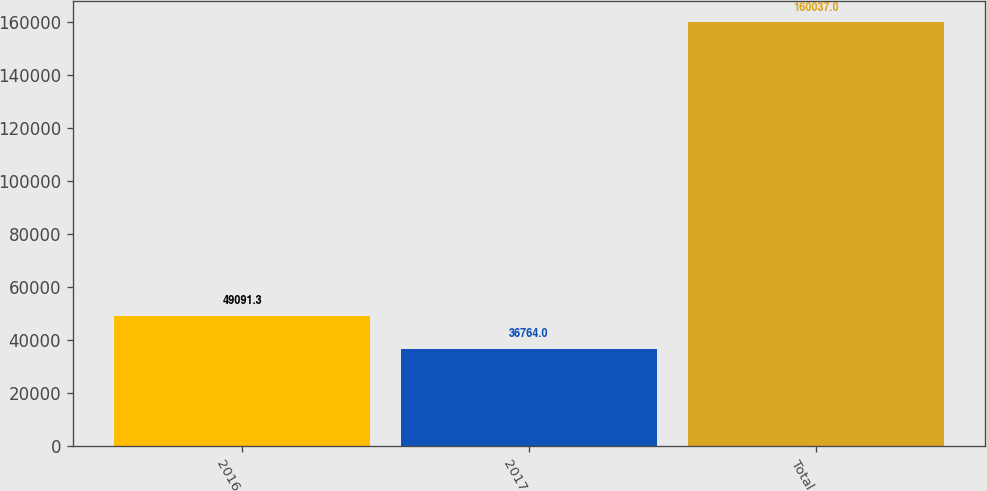Convert chart to OTSL. <chart><loc_0><loc_0><loc_500><loc_500><bar_chart><fcel>2016<fcel>2017<fcel>Total<nl><fcel>49091.3<fcel>36764<fcel>160037<nl></chart> 